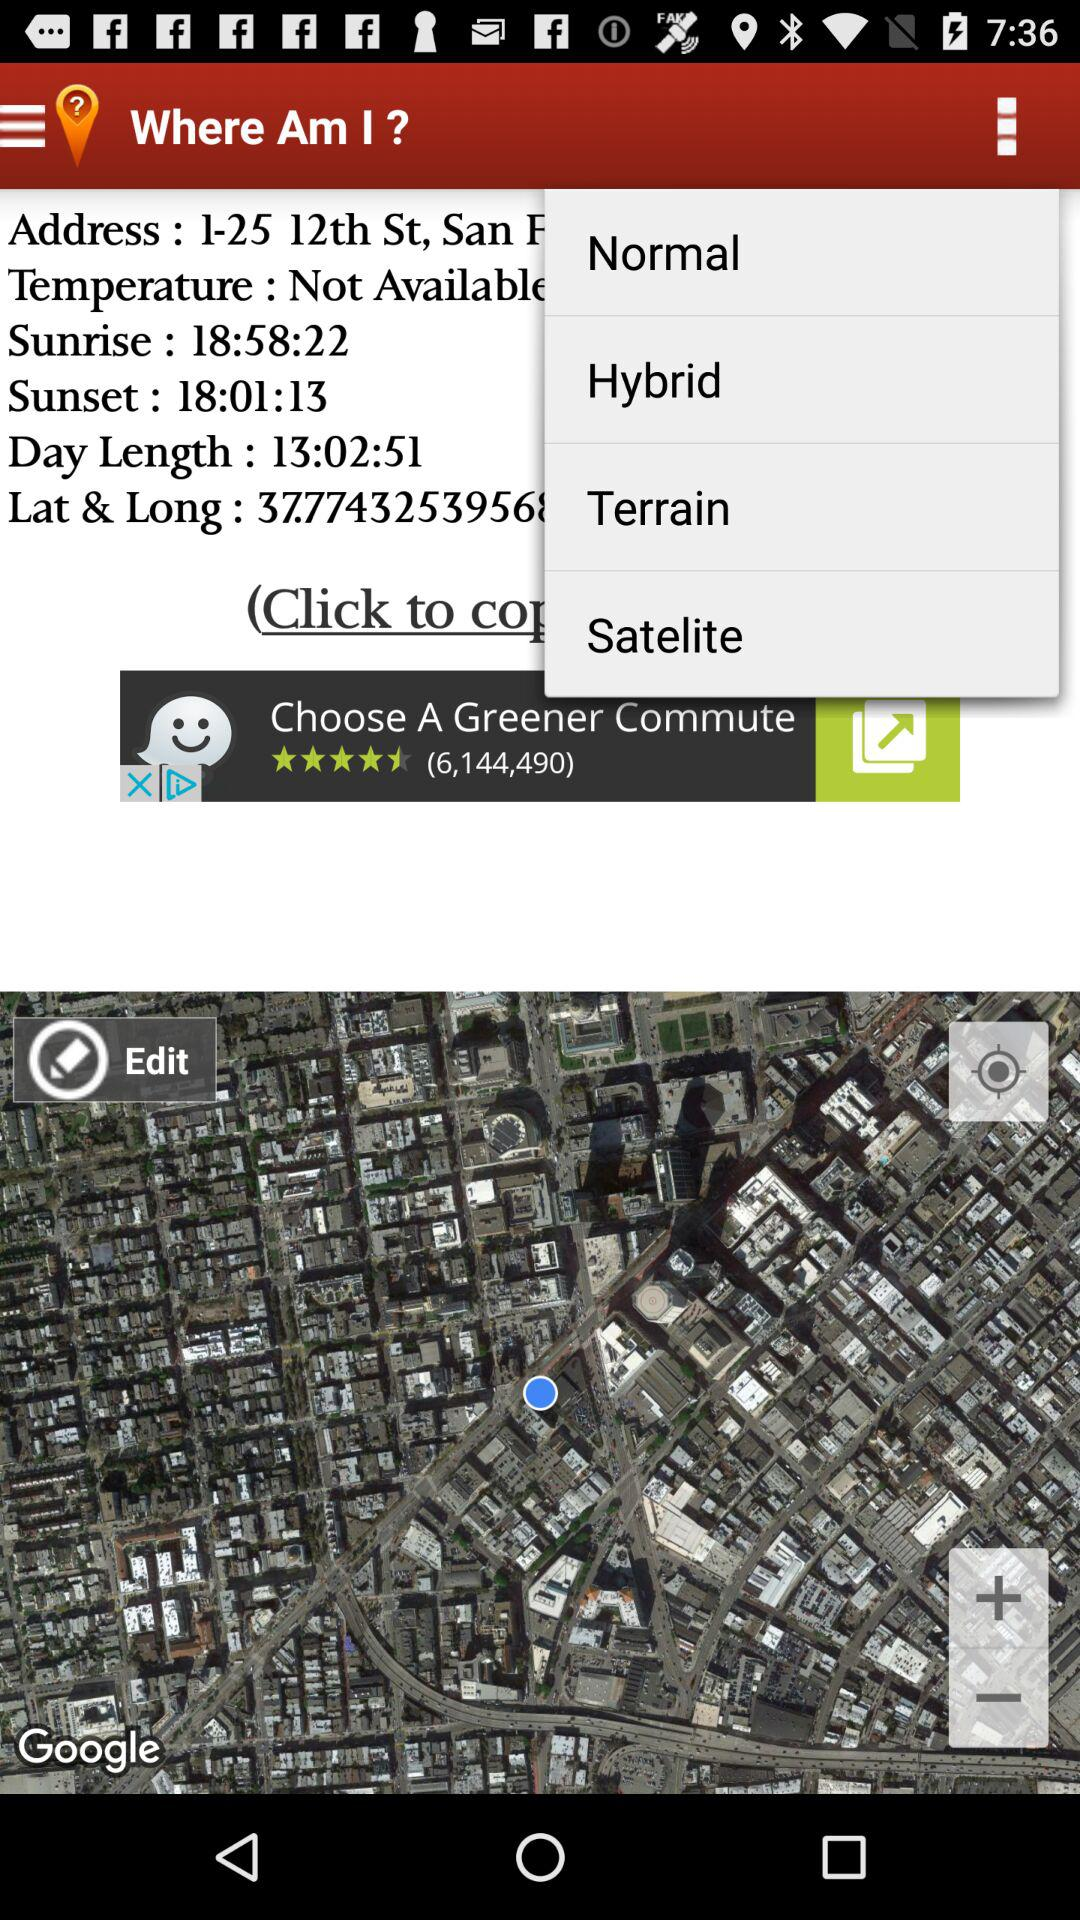What is the length of the day? The length of the day is 13 hours 2 minutes 51 seconds. 